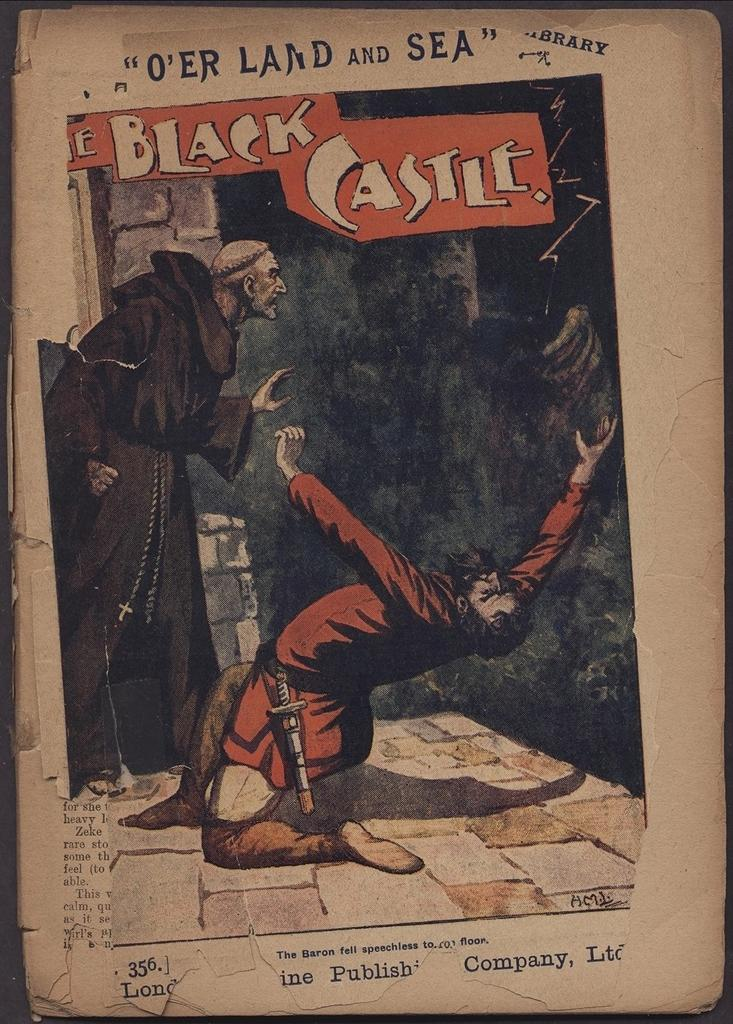<image>
Render a clear and concise summary of the photo. An old drawing with the caption The Black Castle. 